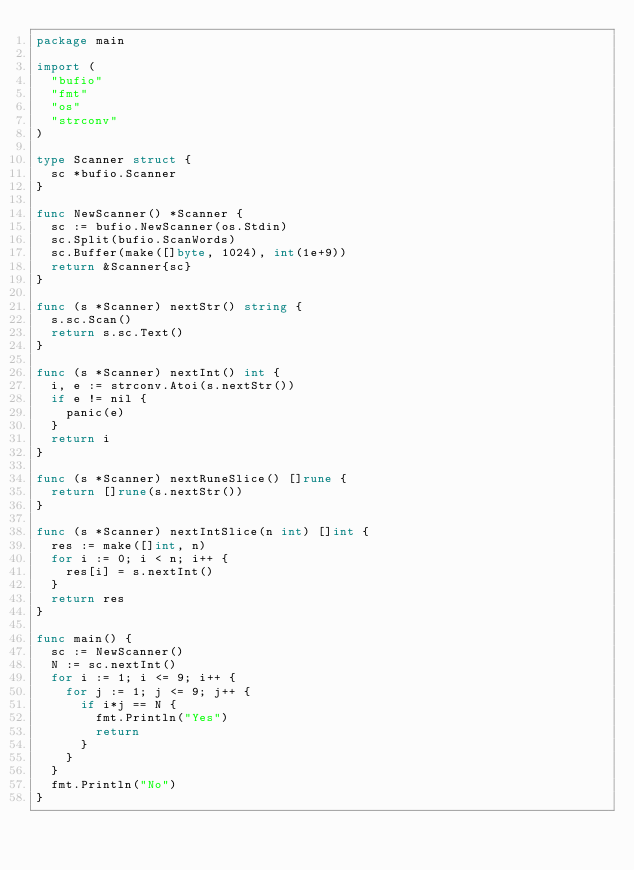Convert code to text. <code><loc_0><loc_0><loc_500><loc_500><_Go_>package main

import (
	"bufio"
	"fmt"
	"os"
	"strconv"
)

type Scanner struct {
	sc *bufio.Scanner
}

func NewScanner() *Scanner {
	sc := bufio.NewScanner(os.Stdin)
	sc.Split(bufio.ScanWords)
	sc.Buffer(make([]byte, 1024), int(1e+9))
	return &Scanner{sc}
}

func (s *Scanner) nextStr() string {
	s.sc.Scan()
	return s.sc.Text()
}

func (s *Scanner) nextInt() int {
	i, e := strconv.Atoi(s.nextStr())
	if e != nil {
		panic(e)
	}
	return i
}

func (s *Scanner) nextRuneSlice() []rune {
	return []rune(s.nextStr())
}

func (s *Scanner) nextIntSlice(n int) []int {
	res := make([]int, n)
	for i := 0; i < n; i++ {
		res[i] = s.nextInt()
	}
	return res
}

func main() {
	sc := NewScanner()
	N := sc.nextInt()
	for i := 1; i <= 9; i++ {
		for j := 1; j <= 9; j++ {
			if i*j == N {
				fmt.Println("Yes")
				return
			}
		}
	}
	fmt.Println("No")
}
</code> 